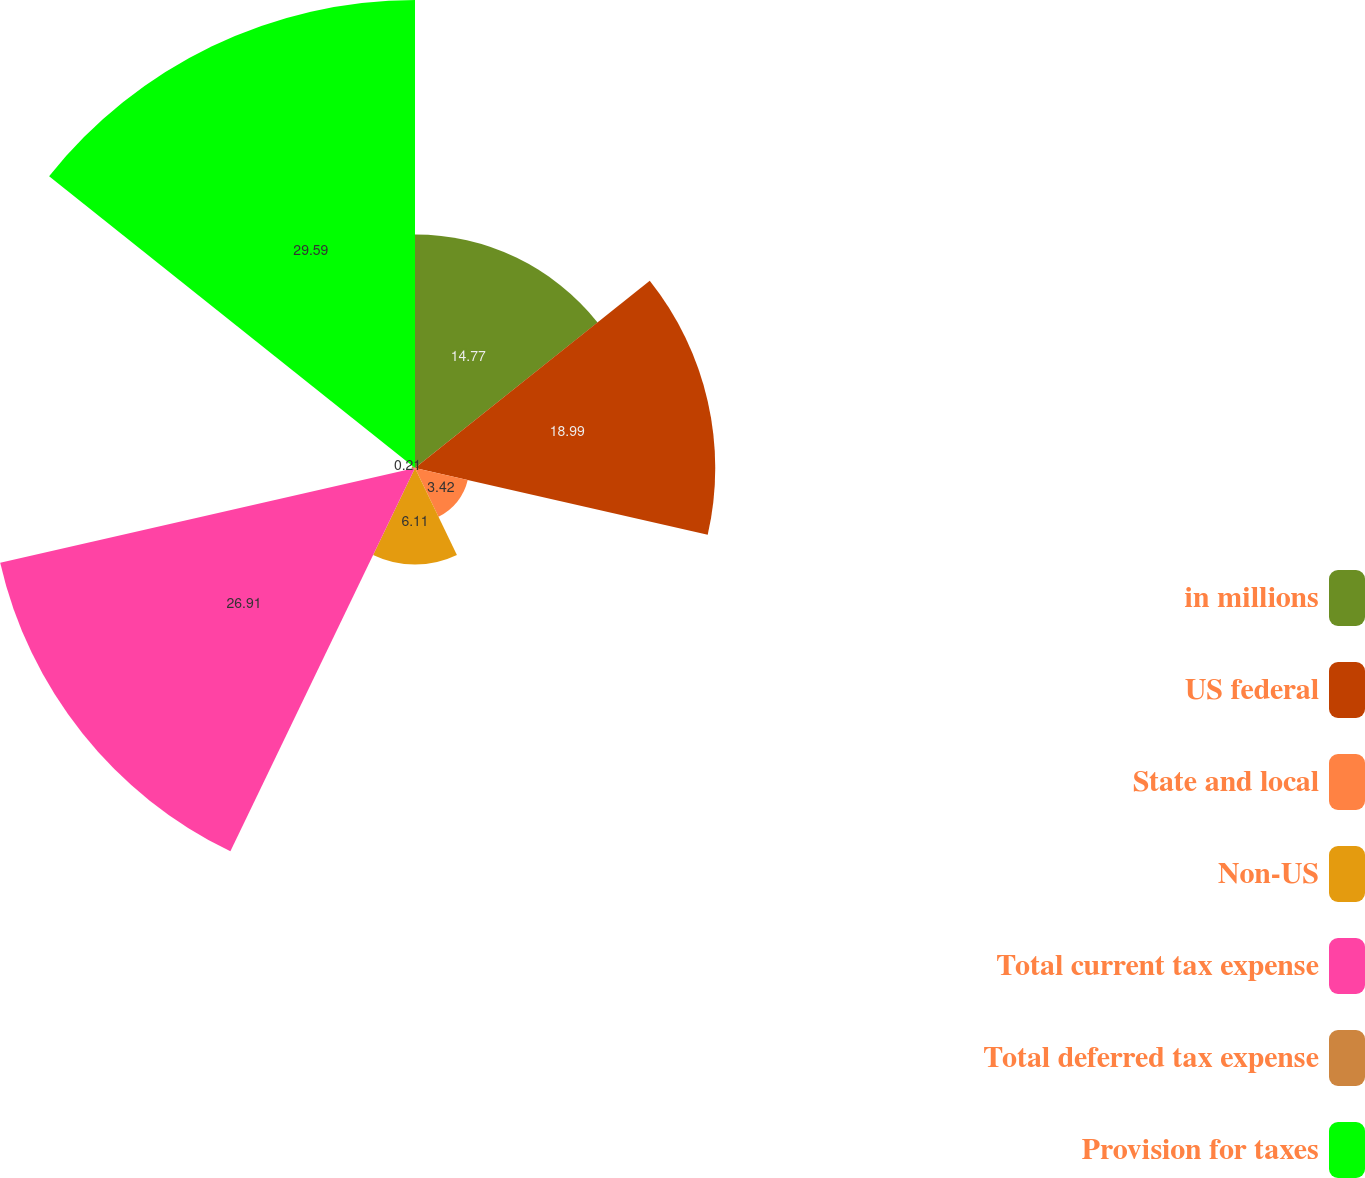Convert chart. <chart><loc_0><loc_0><loc_500><loc_500><pie_chart><fcel>in millions<fcel>US federal<fcel>State and local<fcel>Non-US<fcel>Total current tax expense<fcel>Total deferred tax expense<fcel>Provision for taxes<nl><fcel>14.77%<fcel>18.99%<fcel>3.42%<fcel>6.11%<fcel>26.91%<fcel>0.21%<fcel>29.6%<nl></chart> 